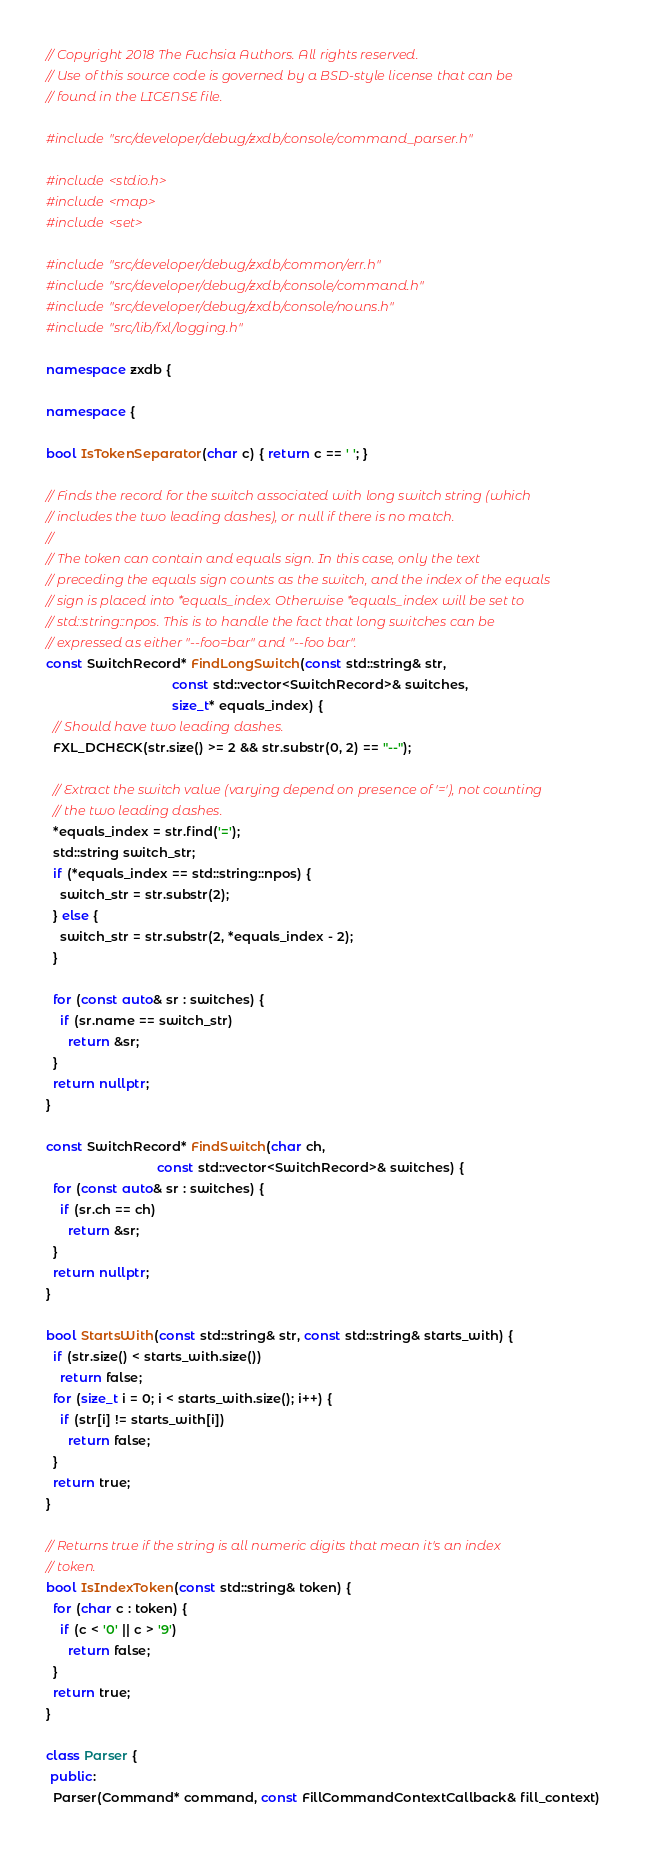<code> <loc_0><loc_0><loc_500><loc_500><_C++_>// Copyright 2018 The Fuchsia Authors. All rights reserved.
// Use of this source code is governed by a BSD-style license that can be
// found in the LICENSE file.

#include "src/developer/debug/zxdb/console/command_parser.h"

#include <stdio.h>
#include <map>
#include <set>

#include "src/developer/debug/zxdb/common/err.h"
#include "src/developer/debug/zxdb/console/command.h"
#include "src/developer/debug/zxdb/console/nouns.h"
#include "src/lib/fxl/logging.h"

namespace zxdb {

namespace {

bool IsTokenSeparator(char c) { return c == ' '; }

// Finds the record for the switch associated with long switch string (which
// includes the two leading dashes), or null if there is no match.
//
// The token can contain and equals sign. In this case, only the text
// preceding the equals sign counts as the switch, and the index of the equals
// sign is placed into *equals_index. Otherwise *equals_index will be set to
// std::string::npos. This is to handle the fact that long switches can be
// expressed as either "--foo=bar" and "--foo bar".
const SwitchRecord* FindLongSwitch(const std::string& str,
                                   const std::vector<SwitchRecord>& switches,
                                   size_t* equals_index) {
  // Should have two leading dashes.
  FXL_DCHECK(str.size() >= 2 && str.substr(0, 2) == "--");

  // Extract the switch value (varying depend on presence of '='), not counting
  // the two leading dashes.
  *equals_index = str.find('=');
  std::string switch_str;
  if (*equals_index == std::string::npos) {
    switch_str = str.substr(2);
  } else {
    switch_str = str.substr(2, *equals_index - 2);
  }

  for (const auto& sr : switches) {
    if (sr.name == switch_str)
      return &sr;
  }
  return nullptr;
}

const SwitchRecord* FindSwitch(char ch,
                               const std::vector<SwitchRecord>& switches) {
  for (const auto& sr : switches) {
    if (sr.ch == ch)
      return &sr;
  }
  return nullptr;
}

bool StartsWith(const std::string& str, const std::string& starts_with) {
  if (str.size() < starts_with.size())
    return false;
  for (size_t i = 0; i < starts_with.size(); i++) {
    if (str[i] != starts_with[i])
      return false;
  }
  return true;
}

// Returns true if the string is all numeric digits that mean it's an index
// token.
bool IsIndexToken(const std::string& token) {
  for (char c : token) {
    if (c < '0' || c > '9')
      return false;
  }
  return true;
}

class Parser {
 public:
  Parser(Command* command, const FillCommandContextCallback& fill_context)</code> 